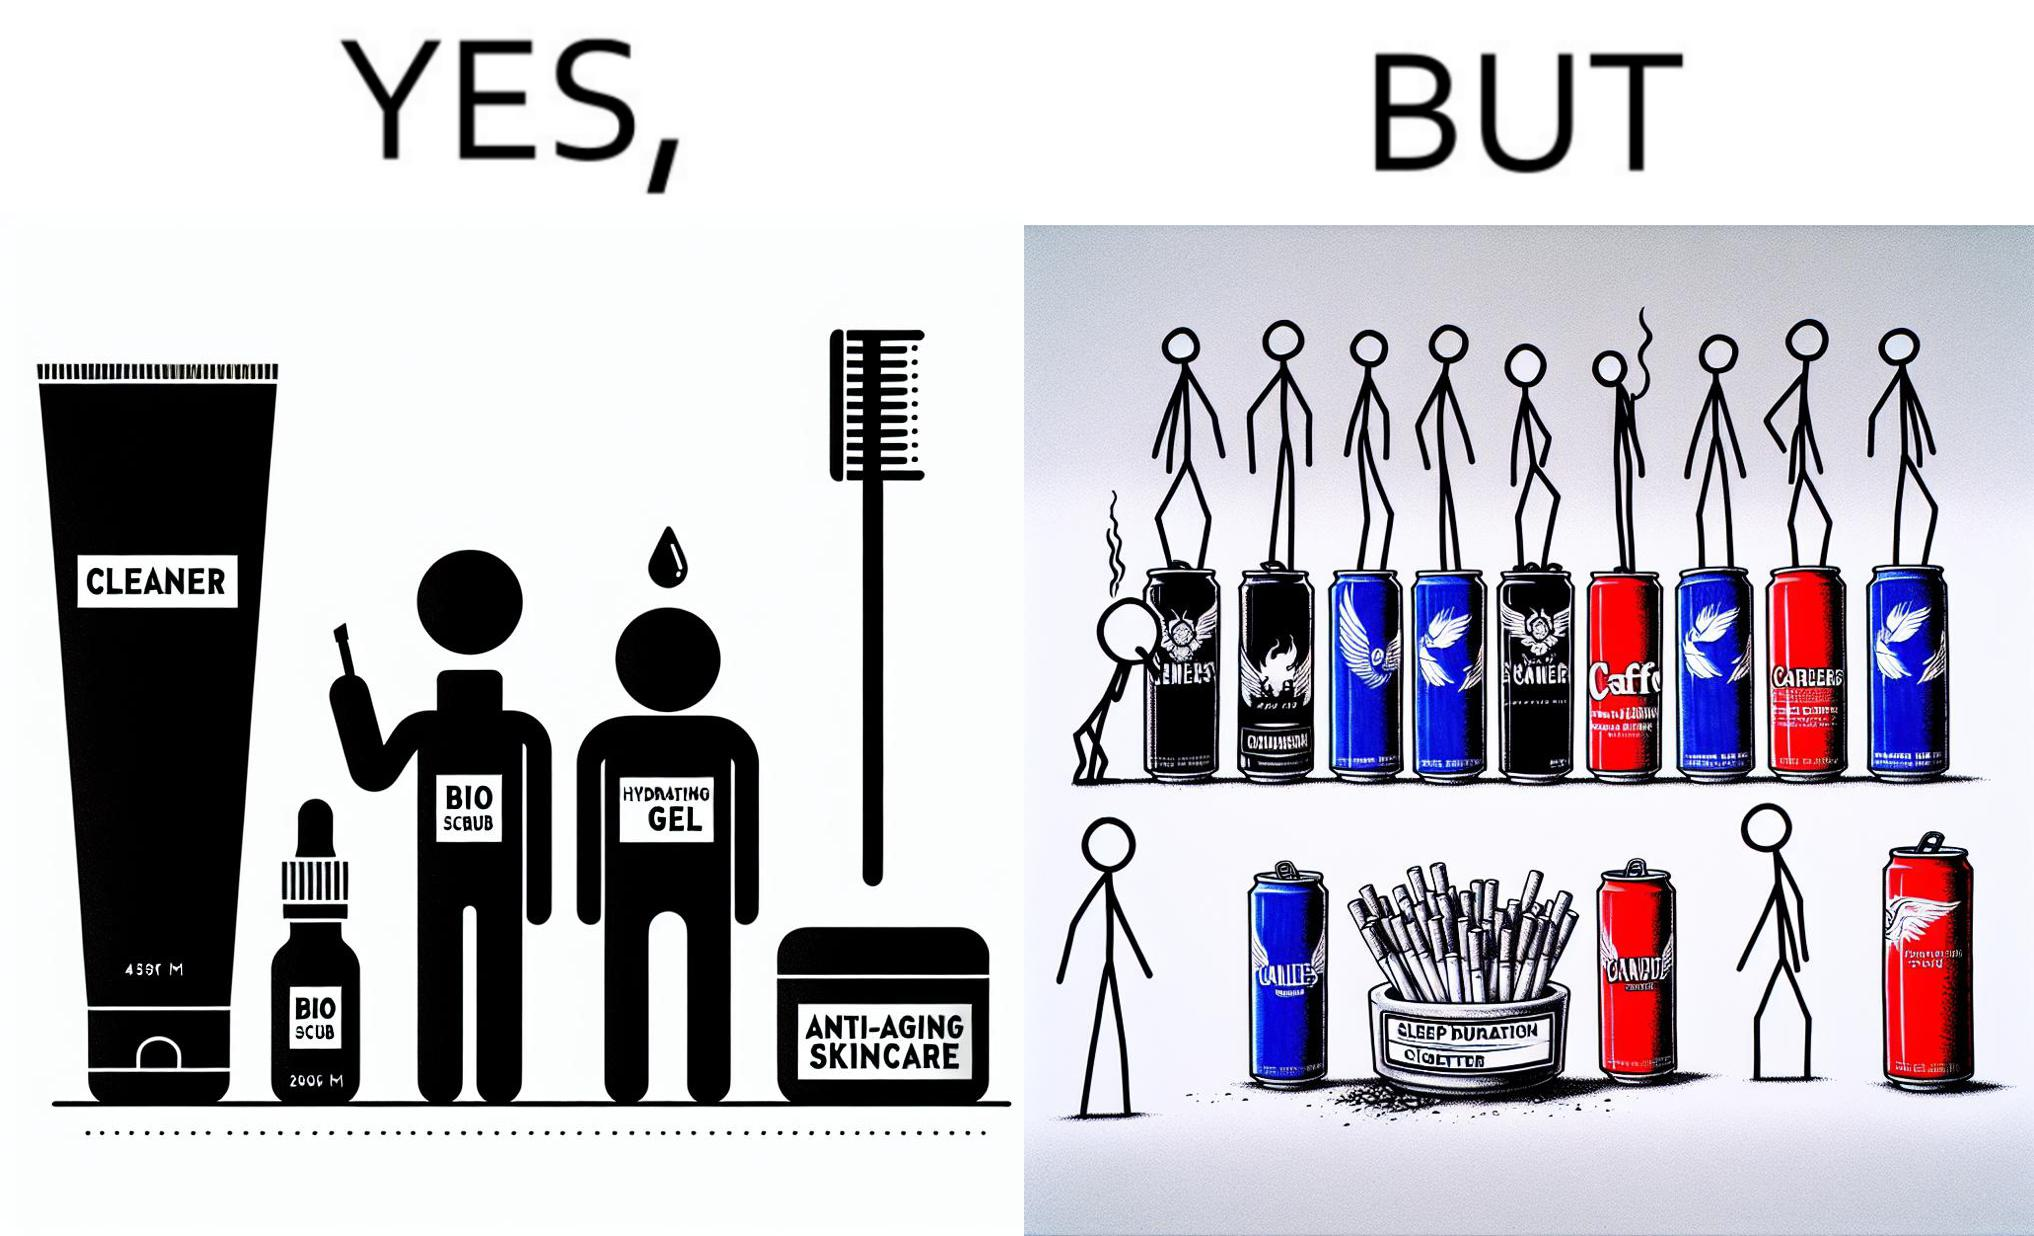Compare the left and right sides of this image. In the left part of the image: 4 Skincare products, arranged aesthetically. A tube labeled "Cleaner". A tube labeled "BIO SCRUB". A dropper bottle labeled "HYDRATING GEL". A jar called "ANTI-AGING SKINCARE". In the right part of the image: 9 cans of red bull, some standing upright, some crushed. Cans have blue and red colors. An ashtray with many cigarette butts in it and has smoke coming out. A banner that says "Sleep duration 2h 5min". 